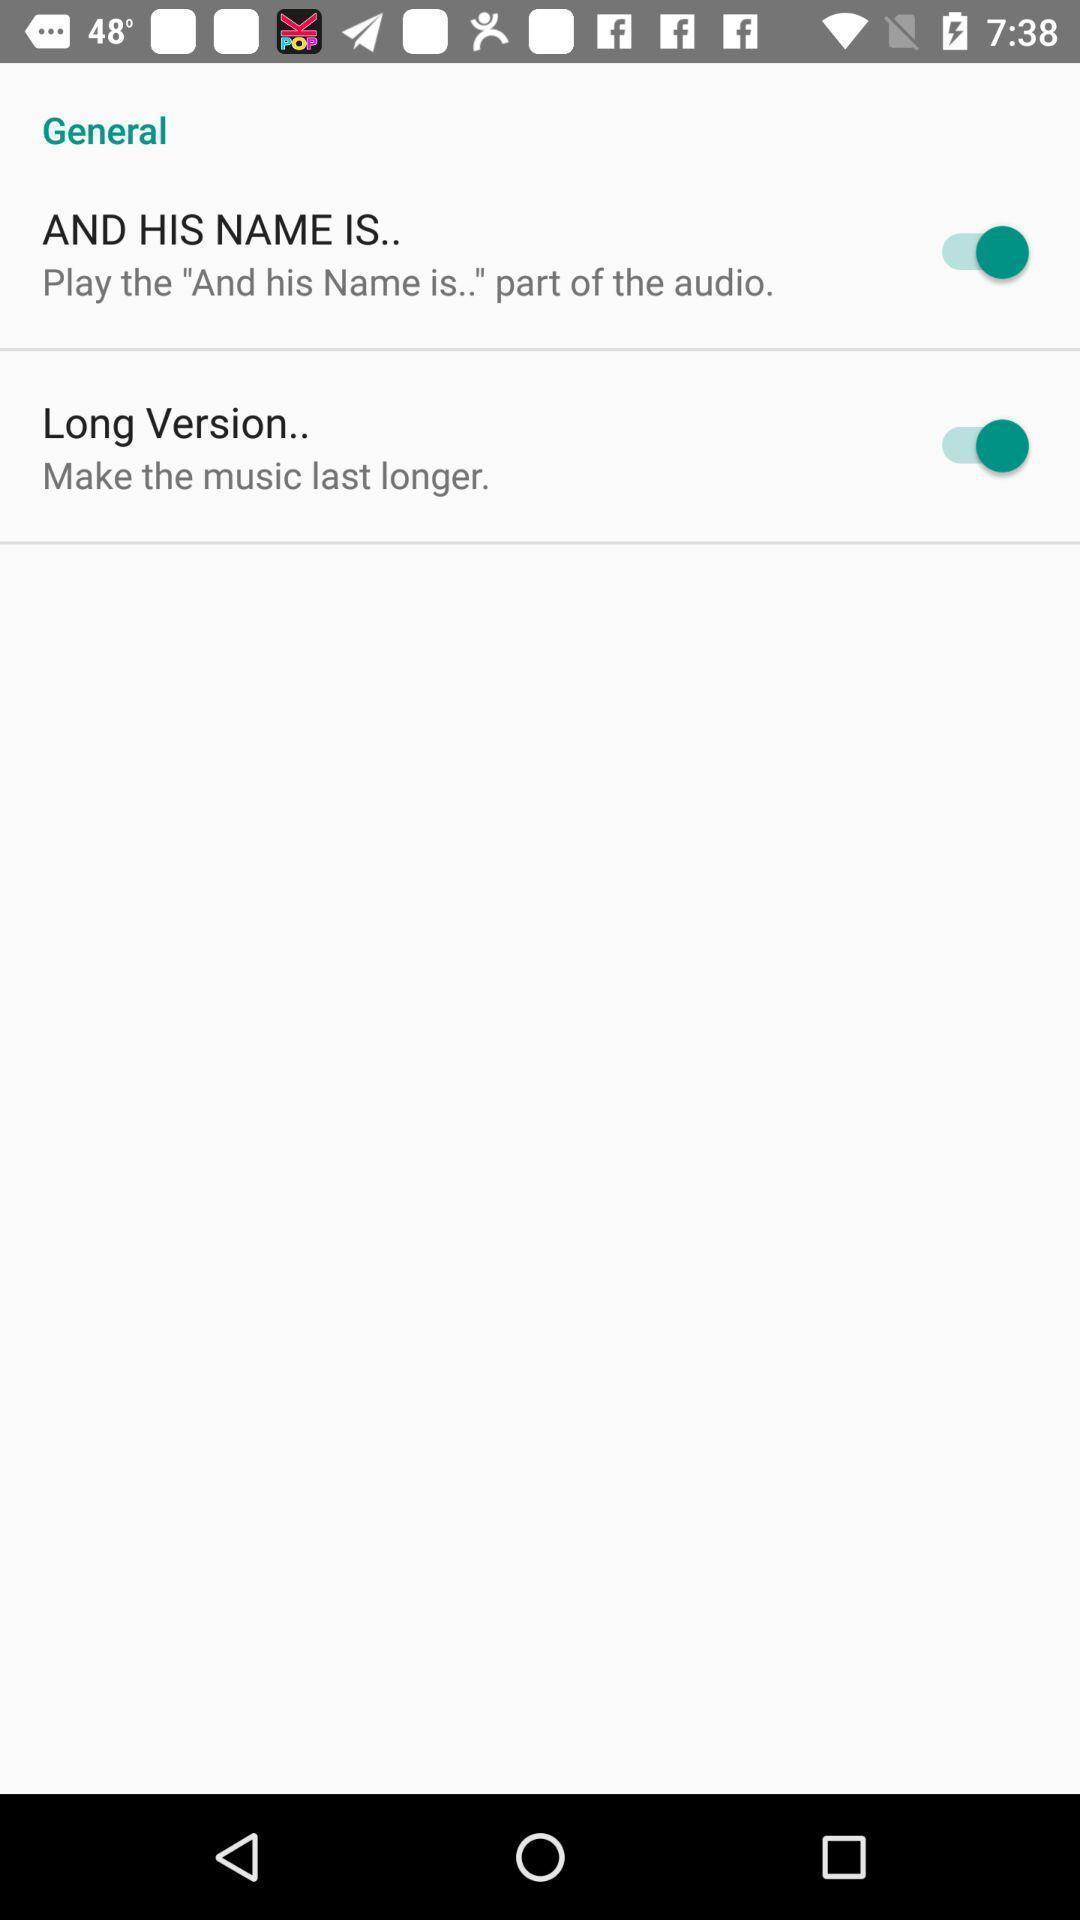What can you discern from this picture? Screen shows general with few options. 